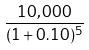<formula> <loc_0><loc_0><loc_500><loc_500>\frac { 1 0 , 0 0 0 } { ( 1 + 0 . 1 0 ) ^ { 5 } }</formula> 